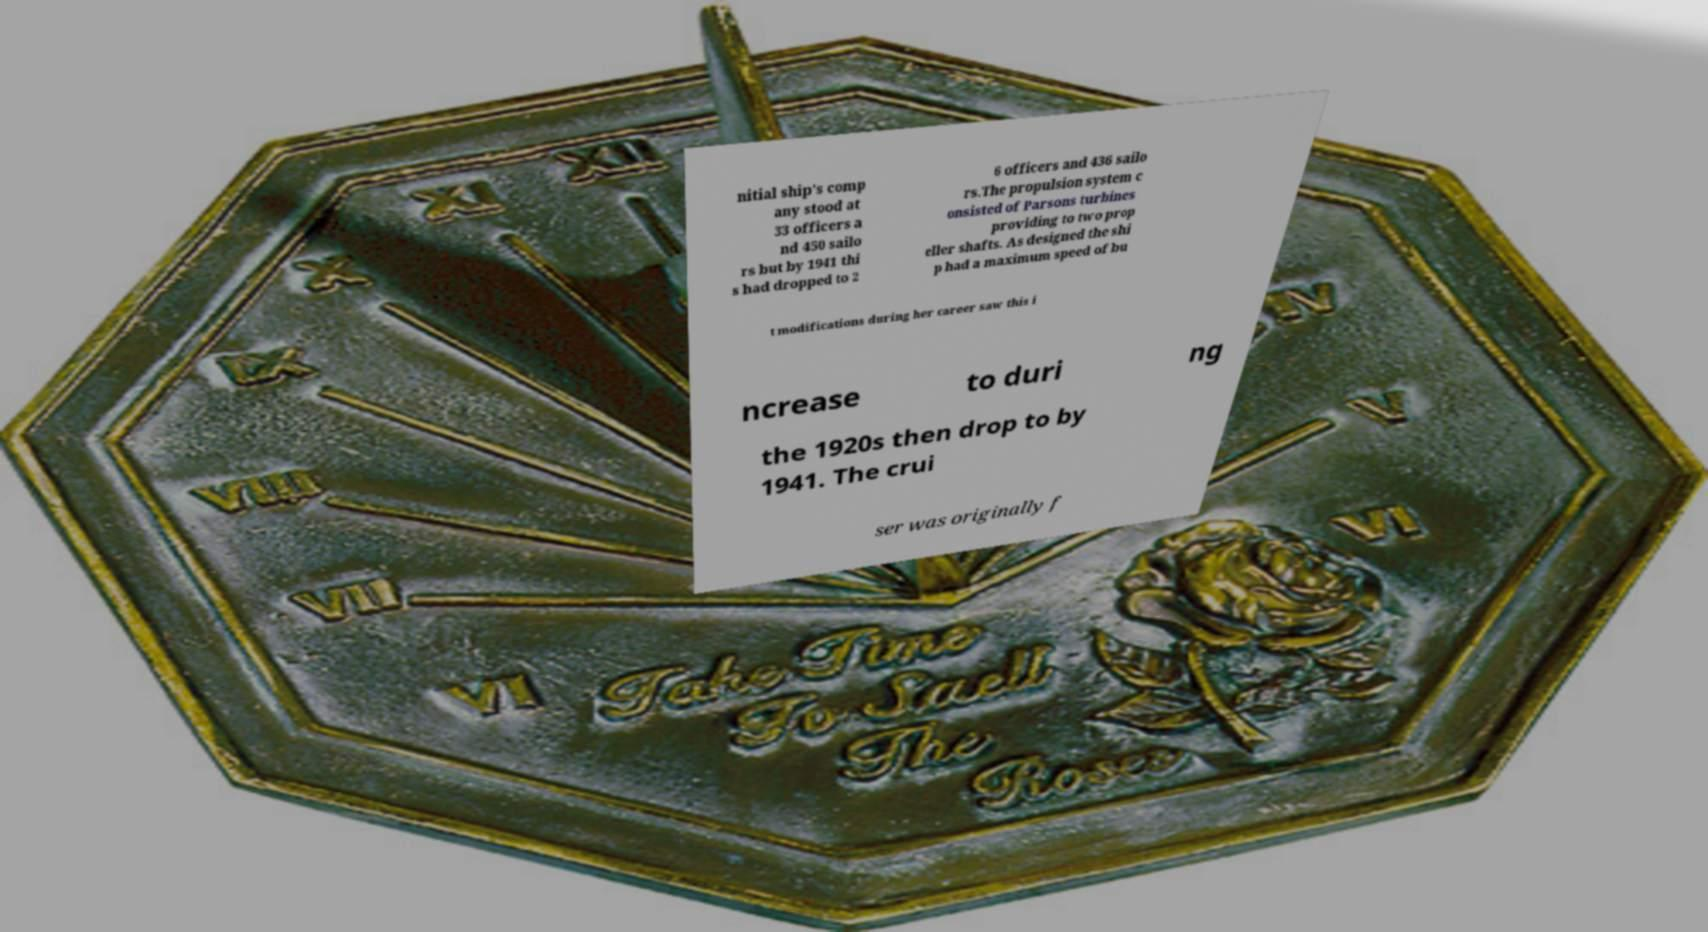Can you read and provide the text displayed in the image?This photo seems to have some interesting text. Can you extract and type it out for me? nitial ship's comp any stood at 33 officers a nd 450 sailo rs but by 1941 thi s had dropped to 2 6 officers and 436 sailo rs.The propulsion system c onsisted of Parsons turbines providing to two prop eller shafts. As designed the shi p had a maximum speed of bu t modifications during her career saw this i ncrease to duri ng the 1920s then drop to by 1941. The crui ser was originally f 